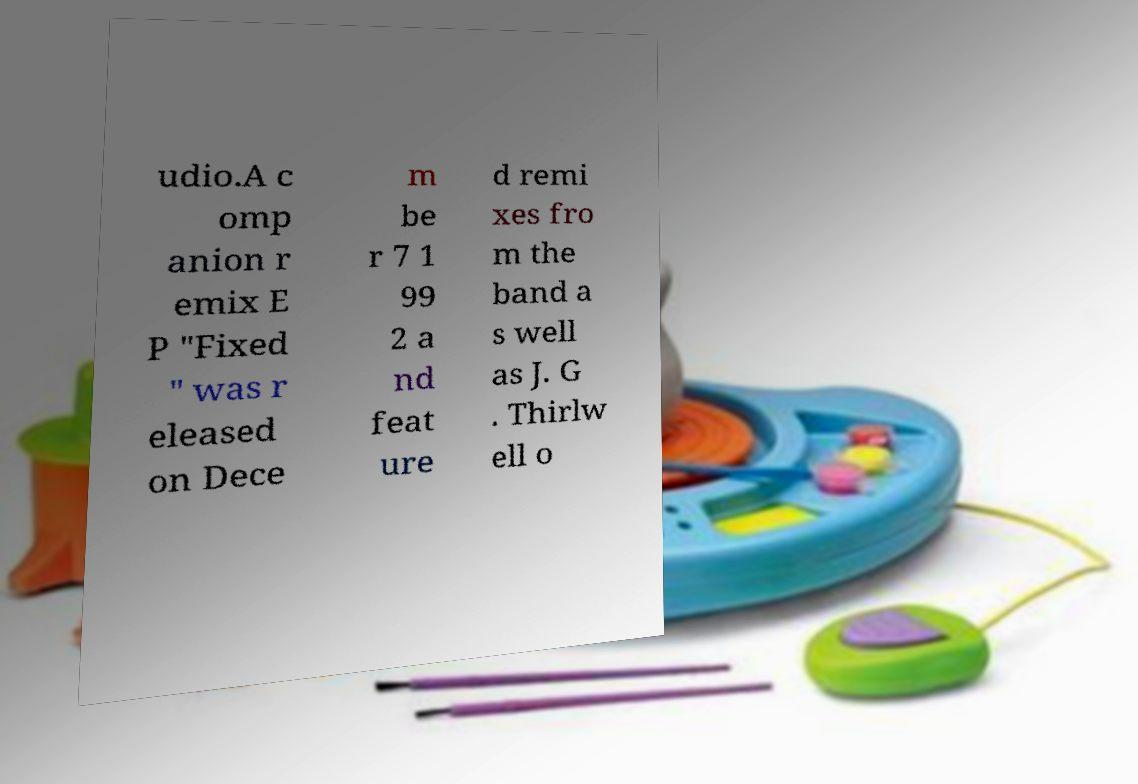Can you read and provide the text displayed in the image?This photo seems to have some interesting text. Can you extract and type it out for me? udio.A c omp anion r emix E P "Fixed " was r eleased on Dece m be r 7 1 99 2 a nd feat ure d remi xes fro m the band a s well as J. G . Thirlw ell o 